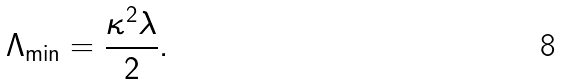Convert formula to latex. <formula><loc_0><loc_0><loc_500><loc_500>\Lambda _ { \min } = \frac { \kappa ^ { 2 } \lambda } { 2 } .</formula> 